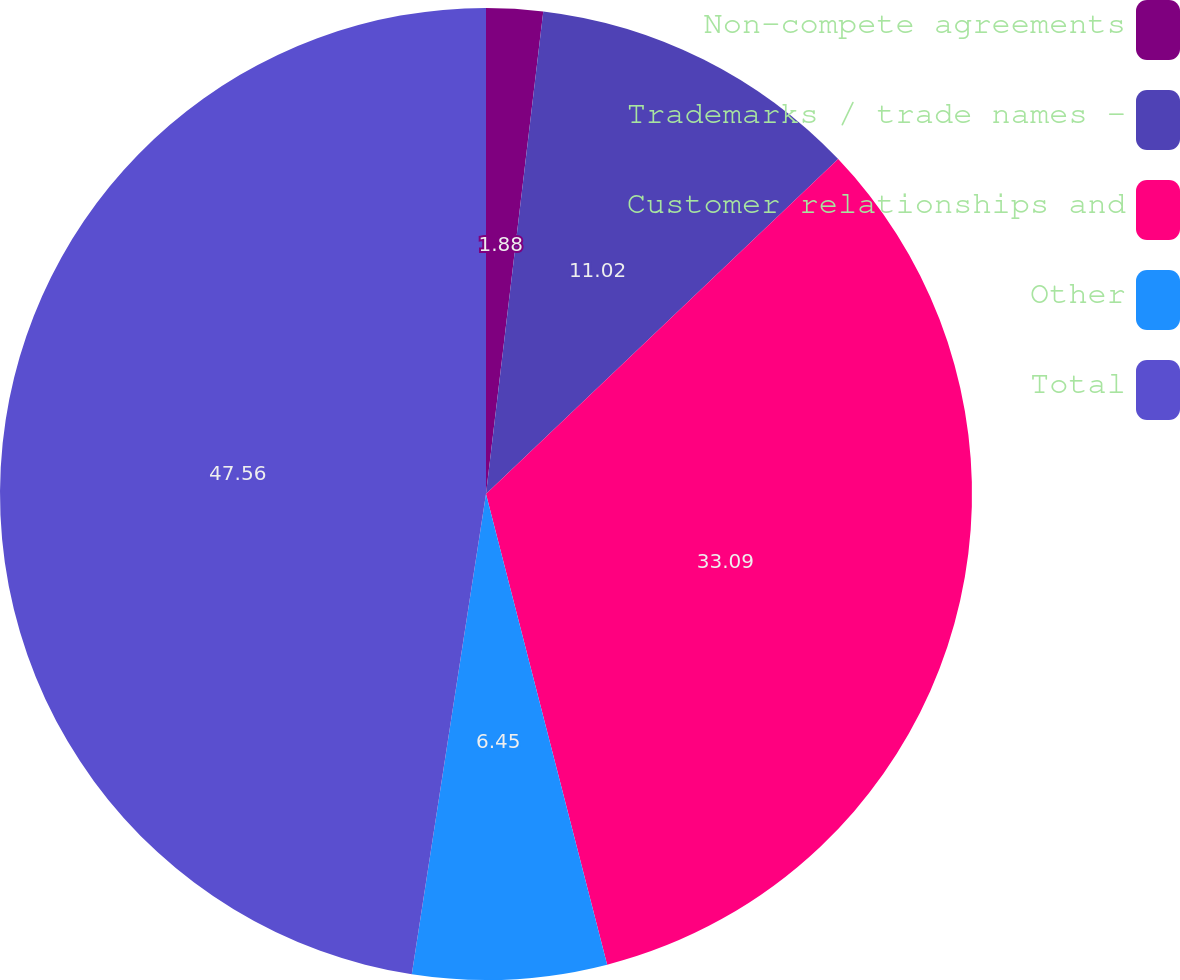Convert chart to OTSL. <chart><loc_0><loc_0><loc_500><loc_500><pie_chart><fcel>Non-compete agreements<fcel>Trademarks / trade names -<fcel>Customer relationships and<fcel>Other<fcel>Total<nl><fcel>1.88%<fcel>11.02%<fcel>33.09%<fcel>6.45%<fcel>47.56%<nl></chart> 